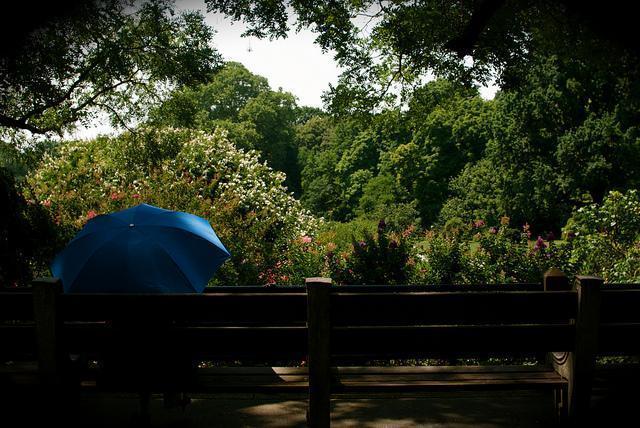How many of the train doors are green?
Give a very brief answer. 0. 